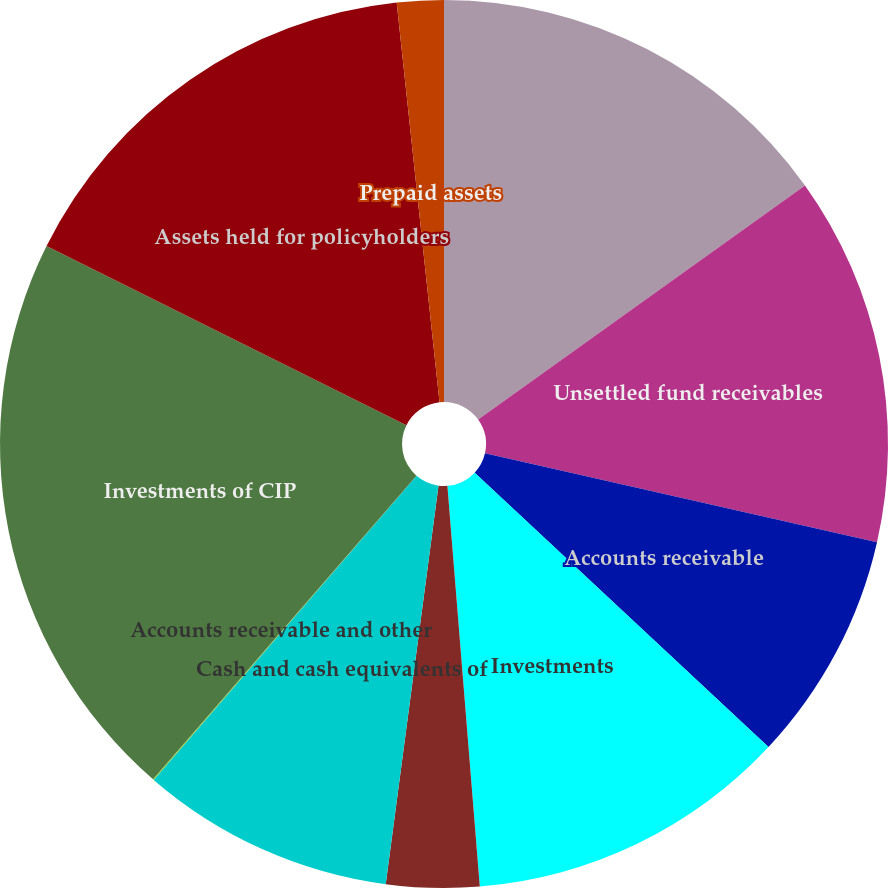Convert chart. <chart><loc_0><loc_0><loc_500><loc_500><pie_chart><fcel>Cash and cash equivalents<fcel>Unsettled fund receivables<fcel>Accounts receivable<fcel>Investments<fcel>Assets of consolidated<fcel>Cash and cash equivalents of<fcel>Accounts receivable and other<fcel>Investments of CIP<fcel>Assets held for policyholders<fcel>Prepaid assets<nl><fcel>15.11%<fcel>13.44%<fcel>8.41%<fcel>11.76%<fcel>3.38%<fcel>9.25%<fcel>0.03%<fcel>20.98%<fcel>15.95%<fcel>1.7%<nl></chart> 